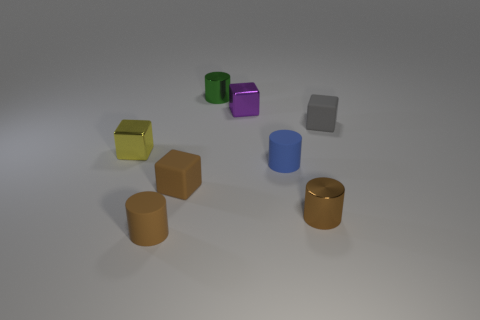Is the number of gray cubes that are in front of the tiny blue matte object greater than the number of things?
Give a very brief answer. No. Do the tiny gray object and the yellow shiny thing have the same shape?
Ensure brevity in your answer.  Yes. Are there more small brown matte cylinders that are in front of the blue cylinder than purple shiny things that are in front of the tiny brown rubber block?
Make the answer very short. Yes. There is a gray object; are there any tiny rubber objects left of it?
Provide a succinct answer. Yes. Is there a blue thing of the same size as the brown matte cylinder?
Your response must be concise. Yes. There is another block that is the same material as the tiny brown cube; what is its color?
Your response must be concise. Gray. What is the tiny yellow thing made of?
Provide a short and direct response. Metal. What is the shape of the tiny gray object?
Offer a terse response. Cube. What material is the small cylinder behind the small block that is behind the matte cube that is behind the tiny yellow object?
Provide a succinct answer. Metal. How many yellow things are metal blocks or small matte balls?
Offer a very short reply. 1. 